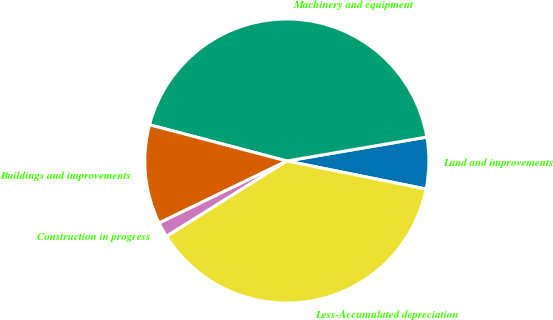<chart> <loc_0><loc_0><loc_500><loc_500><pie_chart><fcel>Land and improvements<fcel>Machinery and equipment<fcel>Buildings and improvements<fcel>Construction in progress<fcel>Less-Accumulated depreciation<nl><fcel>5.86%<fcel>43.2%<fcel>11.3%<fcel>1.71%<fcel>37.94%<nl></chart> 